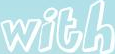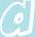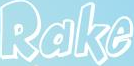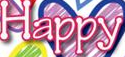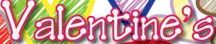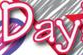What text is displayed in these images sequentially, separated by a semicolon? with; a; Rake; Happy; Valentine's; Day 